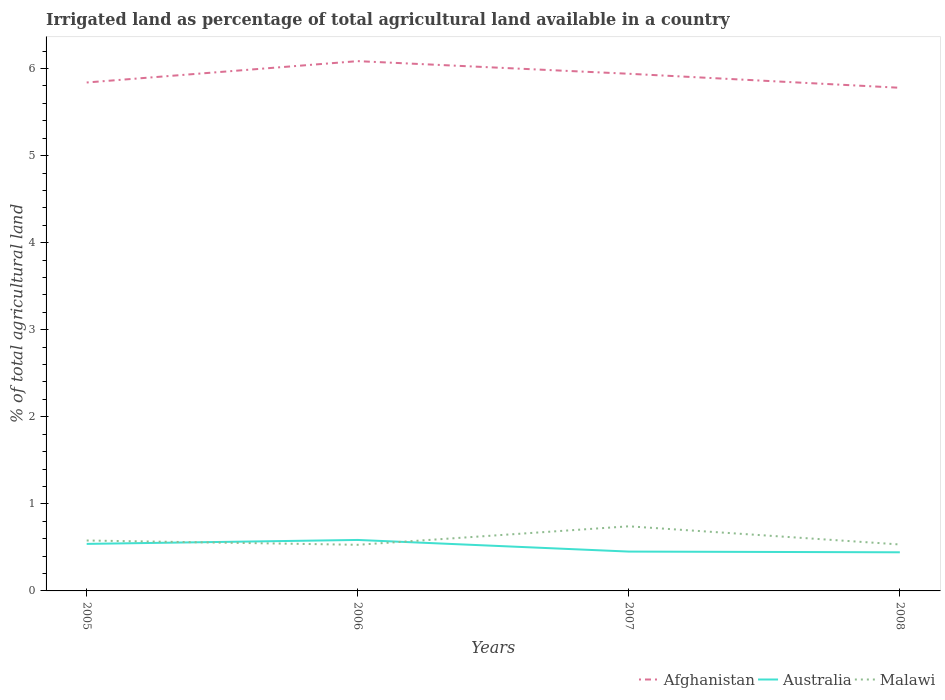How many different coloured lines are there?
Your response must be concise. 3. Does the line corresponding to Malawi intersect with the line corresponding to Afghanistan?
Provide a short and direct response. No. Across all years, what is the maximum percentage of irrigated land in Afghanistan?
Offer a very short reply. 5.78. In which year was the percentage of irrigated land in Afghanistan maximum?
Keep it short and to the point. 2008. What is the total percentage of irrigated land in Australia in the graph?
Offer a terse response. 0.1. What is the difference between the highest and the second highest percentage of irrigated land in Malawi?
Provide a succinct answer. 0.21. What is the difference between the highest and the lowest percentage of irrigated land in Malawi?
Offer a very short reply. 1. How many lines are there?
Offer a terse response. 3. Are the values on the major ticks of Y-axis written in scientific E-notation?
Ensure brevity in your answer.  No. How many legend labels are there?
Keep it short and to the point. 3. How are the legend labels stacked?
Offer a terse response. Horizontal. What is the title of the graph?
Your answer should be compact. Irrigated land as percentage of total agricultural land available in a country. Does "Mauritania" appear as one of the legend labels in the graph?
Provide a short and direct response. No. What is the label or title of the X-axis?
Give a very brief answer. Years. What is the label or title of the Y-axis?
Give a very brief answer. % of total agricultural land. What is the % of total agricultural land of Afghanistan in 2005?
Offer a terse response. 5.84. What is the % of total agricultural land in Australia in 2005?
Provide a succinct answer. 0.54. What is the % of total agricultural land of Malawi in 2005?
Ensure brevity in your answer.  0.58. What is the % of total agricultural land in Afghanistan in 2006?
Provide a short and direct response. 6.09. What is the % of total agricultural land in Australia in 2006?
Offer a very short reply. 0.59. What is the % of total agricultural land in Malawi in 2006?
Your response must be concise. 0.53. What is the % of total agricultural land in Afghanistan in 2007?
Provide a succinct answer. 5.94. What is the % of total agricultural land of Australia in 2007?
Keep it short and to the point. 0.45. What is the % of total agricultural land in Malawi in 2007?
Keep it short and to the point. 0.74. What is the % of total agricultural land of Afghanistan in 2008?
Provide a succinct answer. 5.78. What is the % of total agricultural land in Australia in 2008?
Offer a very short reply. 0.44. What is the % of total agricultural land of Malawi in 2008?
Ensure brevity in your answer.  0.53. Across all years, what is the maximum % of total agricultural land in Afghanistan?
Ensure brevity in your answer.  6.09. Across all years, what is the maximum % of total agricultural land of Australia?
Give a very brief answer. 0.59. Across all years, what is the maximum % of total agricultural land in Malawi?
Ensure brevity in your answer.  0.74. Across all years, what is the minimum % of total agricultural land in Afghanistan?
Offer a terse response. 5.78. Across all years, what is the minimum % of total agricultural land in Australia?
Your response must be concise. 0.44. Across all years, what is the minimum % of total agricultural land in Malawi?
Provide a short and direct response. 0.53. What is the total % of total agricultural land of Afghanistan in the graph?
Provide a short and direct response. 23.65. What is the total % of total agricultural land in Australia in the graph?
Provide a short and direct response. 2.02. What is the total % of total agricultural land of Malawi in the graph?
Give a very brief answer. 2.38. What is the difference between the % of total agricultural land in Afghanistan in 2005 and that in 2006?
Provide a short and direct response. -0.25. What is the difference between the % of total agricultural land of Australia in 2005 and that in 2006?
Make the answer very short. -0.05. What is the difference between the % of total agricultural land in Malawi in 2005 and that in 2006?
Provide a short and direct response. 0.05. What is the difference between the % of total agricultural land of Afghanistan in 2005 and that in 2007?
Ensure brevity in your answer.  -0.1. What is the difference between the % of total agricultural land of Australia in 2005 and that in 2007?
Ensure brevity in your answer.  0.09. What is the difference between the % of total agricultural land in Malawi in 2005 and that in 2007?
Ensure brevity in your answer.  -0.16. What is the difference between the % of total agricultural land in Afghanistan in 2005 and that in 2008?
Make the answer very short. 0.06. What is the difference between the % of total agricultural land of Australia in 2005 and that in 2008?
Offer a very short reply. 0.1. What is the difference between the % of total agricultural land in Malawi in 2005 and that in 2008?
Your answer should be compact. 0.05. What is the difference between the % of total agricultural land in Afghanistan in 2006 and that in 2007?
Your answer should be very brief. 0.15. What is the difference between the % of total agricultural land in Australia in 2006 and that in 2007?
Your response must be concise. 0.13. What is the difference between the % of total agricultural land of Malawi in 2006 and that in 2007?
Make the answer very short. -0.21. What is the difference between the % of total agricultural land of Afghanistan in 2006 and that in 2008?
Provide a short and direct response. 0.31. What is the difference between the % of total agricultural land in Australia in 2006 and that in 2008?
Make the answer very short. 0.14. What is the difference between the % of total agricultural land of Malawi in 2006 and that in 2008?
Give a very brief answer. -0. What is the difference between the % of total agricultural land in Afghanistan in 2007 and that in 2008?
Give a very brief answer. 0.16. What is the difference between the % of total agricultural land in Australia in 2007 and that in 2008?
Offer a terse response. 0.01. What is the difference between the % of total agricultural land in Malawi in 2007 and that in 2008?
Provide a short and direct response. 0.21. What is the difference between the % of total agricultural land of Afghanistan in 2005 and the % of total agricultural land of Australia in 2006?
Offer a very short reply. 5.25. What is the difference between the % of total agricultural land in Afghanistan in 2005 and the % of total agricultural land in Malawi in 2006?
Keep it short and to the point. 5.31. What is the difference between the % of total agricultural land of Australia in 2005 and the % of total agricultural land of Malawi in 2006?
Make the answer very short. 0.01. What is the difference between the % of total agricultural land in Afghanistan in 2005 and the % of total agricultural land in Australia in 2007?
Give a very brief answer. 5.39. What is the difference between the % of total agricultural land in Afghanistan in 2005 and the % of total agricultural land in Malawi in 2007?
Make the answer very short. 5.1. What is the difference between the % of total agricultural land in Australia in 2005 and the % of total agricultural land in Malawi in 2007?
Your answer should be compact. -0.2. What is the difference between the % of total agricultural land in Afghanistan in 2005 and the % of total agricultural land in Australia in 2008?
Keep it short and to the point. 5.4. What is the difference between the % of total agricultural land of Afghanistan in 2005 and the % of total agricultural land of Malawi in 2008?
Provide a short and direct response. 5.31. What is the difference between the % of total agricultural land in Australia in 2005 and the % of total agricultural land in Malawi in 2008?
Your response must be concise. 0.01. What is the difference between the % of total agricultural land of Afghanistan in 2006 and the % of total agricultural land of Australia in 2007?
Your response must be concise. 5.63. What is the difference between the % of total agricultural land of Afghanistan in 2006 and the % of total agricultural land of Malawi in 2007?
Provide a short and direct response. 5.34. What is the difference between the % of total agricultural land in Australia in 2006 and the % of total agricultural land in Malawi in 2007?
Offer a terse response. -0.16. What is the difference between the % of total agricultural land of Afghanistan in 2006 and the % of total agricultural land of Australia in 2008?
Offer a terse response. 5.64. What is the difference between the % of total agricultural land in Afghanistan in 2006 and the % of total agricultural land in Malawi in 2008?
Ensure brevity in your answer.  5.55. What is the difference between the % of total agricultural land of Australia in 2006 and the % of total agricultural land of Malawi in 2008?
Ensure brevity in your answer.  0.05. What is the difference between the % of total agricultural land in Afghanistan in 2007 and the % of total agricultural land in Australia in 2008?
Give a very brief answer. 5.5. What is the difference between the % of total agricultural land of Afghanistan in 2007 and the % of total agricultural land of Malawi in 2008?
Provide a short and direct response. 5.41. What is the difference between the % of total agricultural land of Australia in 2007 and the % of total agricultural land of Malawi in 2008?
Give a very brief answer. -0.08. What is the average % of total agricultural land in Afghanistan per year?
Offer a very short reply. 5.91. What is the average % of total agricultural land of Australia per year?
Give a very brief answer. 0.51. What is the average % of total agricultural land of Malawi per year?
Your answer should be very brief. 0.6. In the year 2005, what is the difference between the % of total agricultural land of Afghanistan and % of total agricultural land of Australia?
Provide a succinct answer. 5.3. In the year 2005, what is the difference between the % of total agricultural land in Afghanistan and % of total agricultural land in Malawi?
Ensure brevity in your answer.  5.26. In the year 2005, what is the difference between the % of total agricultural land in Australia and % of total agricultural land in Malawi?
Your answer should be very brief. -0.04. In the year 2006, what is the difference between the % of total agricultural land of Afghanistan and % of total agricultural land of Australia?
Make the answer very short. 5.5. In the year 2006, what is the difference between the % of total agricultural land of Afghanistan and % of total agricultural land of Malawi?
Keep it short and to the point. 5.56. In the year 2006, what is the difference between the % of total agricultural land in Australia and % of total agricultural land in Malawi?
Your answer should be compact. 0.06. In the year 2007, what is the difference between the % of total agricultural land in Afghanistan and % of total agricultural land in Australia?
Provide a succinct answer. 5.49. In the year 2007, what is the difference between the % of total agricultural land in Afghanistan and % of total agricultural land in Malawi?
Keep it short and to the point. 5.2. In the year 2007, what is the difference between the % of total agricultural land of Australia and % of total agricultural land of Malawi?
Provide a short and direct response. -0.29. In the year 2008, what is the difference between the % of total agricultural land of Afghanistan and % of total agricultural land of Australia?
Your answer should be compact. 5.34. In the year 2008, what is the difference between the % of total agricultural land of Afghanistan and % of total agricultural land of Malawi?
Ensure brevity in your answer.  5.25. In the year 2008, what is the difference between the % of total agricultural land in Australia and % of total agricultural land in Malawi?
Ensure brevity in your answer.  -0.09. What is the ratio of the % of total agricultural land in Afghanistan in 2005 to that in 2006?
Your answer should be compact. 0.96. What is the ratio of the % of total agricultural land of Australia in 2005 to that in 2006?
Keep it short and to the point. 0.92. What is the ratio of the % of total agricultural land of Malawi in 2005 to that in 2006?
Your answer should be very brief. 1.09. What is the ratio of the % of total agricultural land in Afghanistan in 2005 to that in 2007?
Your response must be concise. 0.98. What is the ratio of the % of total agricultural land of Australia in 2005 to that in 2007?
Offer a terse response. 1.2. What is the ratio of the % of total agricultural land in Malawi in 2005 to that in 2007?
Your response must be concise. 0.78. What is the ratio of the % of total agricultural land of Afghanistan in 2005 to that in 2008?
Keep it short and to the point. 1.01. What is the ratio of the % of total agricultural land of Australia in 2005 to that in 2008?
Offer a terse response. 1.22. What is the ratio of the % of total agricultural land of Malawi in 2005 to that in 2008?
Offer a very short reply. 1.09. What is the ratio of the % of total agricultural land of Afghanistan in 2006 to that in 2007?
Offer a terse response. 1.02. What is the ratio of the % of total agricultural land in Australia in 2006 to that in 2007?
Provide a short and direct response. 1.3. What is the ratio of the % of total agricultural land of Malawi in 2006 to that in 2007?
Your response must be concise. 0.71. What is the ratio of the % of total agricultural land in Afghanistan in 2006 to that in 2008?
Your answer should be compact. 1.05. What is the ratio of the % of total agricultural land of Australia in 2006 to that in 2008?
Your answer should be very brief. 1.32. What is the ratio of the % of total agricultural land in Afghanistan in 2007 to that in 2008?
Keep it short and to the point. 1.03. What is the ratio of the % of total agricultural land of Malawi in 2007 to that in 2008?
Your answer should be compact. 1.39. What is the difference between the highest and the second highest % of total agricultural land of Afghanistan?
Offer a very short reply. 0.15. What is the difference between the highest and the second highest % of total agricultural land in Australia?
Offer a terse response. 0.05. What is the difference between the highest and the second highest % of total agricultural land in Malawi?
Ensure brevity in your answer.  0.16. What is the difference between the highest and the lowest % of total agricultural land of Afghanistan?
Provide a short and direct response. 0.31. What is the difference between the highest and the lowest % of total agricultural land of Australia?
Make the answer very short. 0.14. What is the difference between the highest and the lowest % of total agricultural land of Malawi?
Your response must be concise. 0.21. 